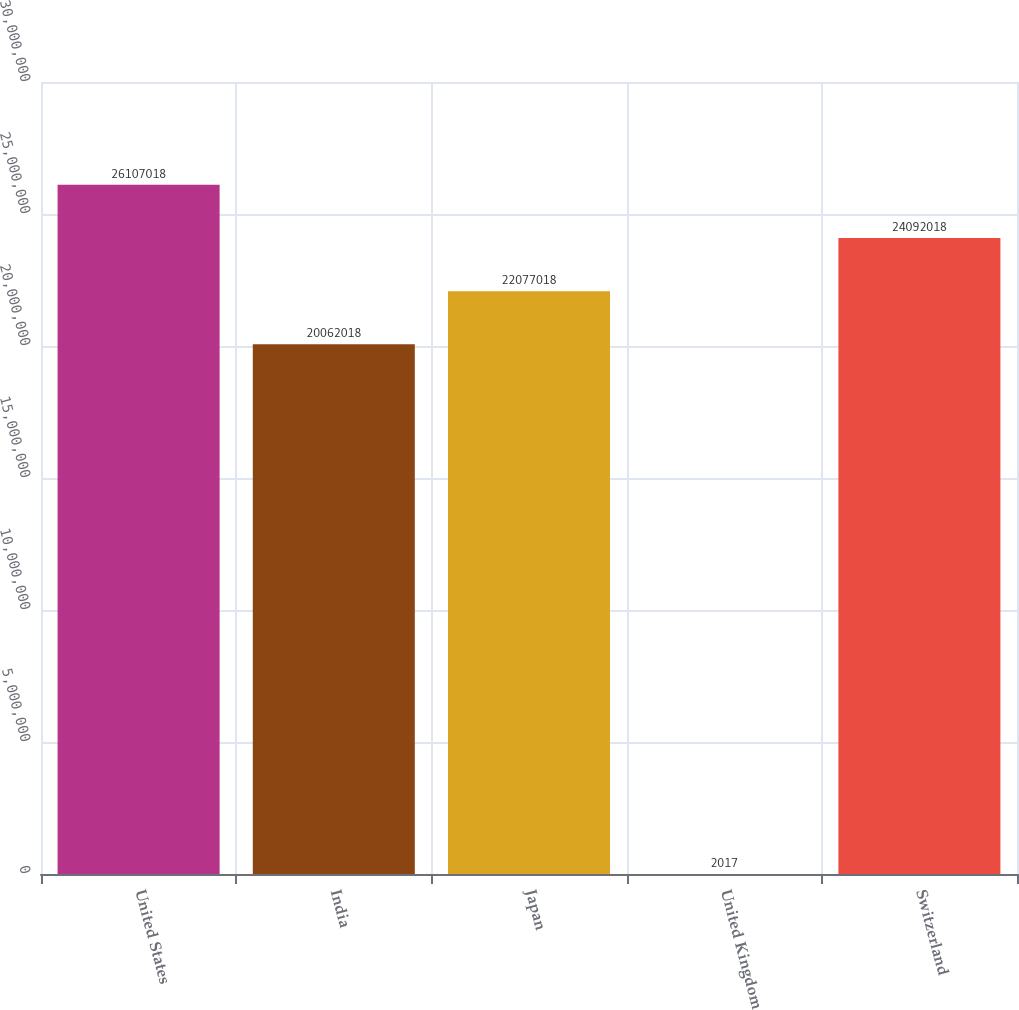<chart> <loc_0><loc_0><loc_500><loc_500><bar_chart><fcel>United States<fcel>India<fcel>Japan<fcel>United Kingdom<fcel>Switzerland<nl><fcel>2.6107e+07<fcel>2.0062e+07<fcel>2.2077e+07<fcel>2017<fcel>2.4092e+07<nl></chart> 